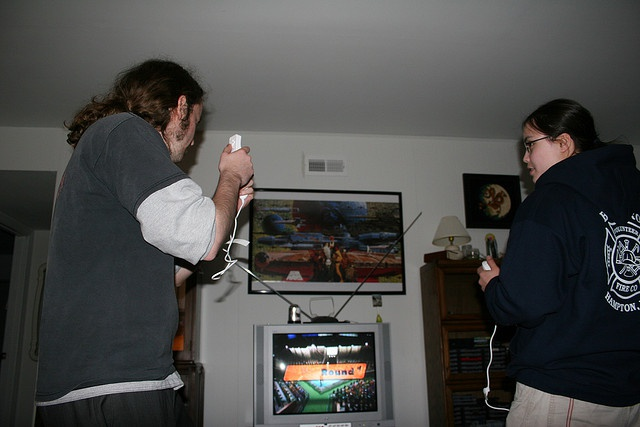Describe the objects in this image and their specific colors. I can see people in black, darkgray, lightgray, and gray tones, people in black, gray, and darkgray tones, tv in black, gray, and maroon tones, tv in black, gray, darkgray, and lightgray tones, and remote in black, lightgray, darkgray, and gray tones in this image. 